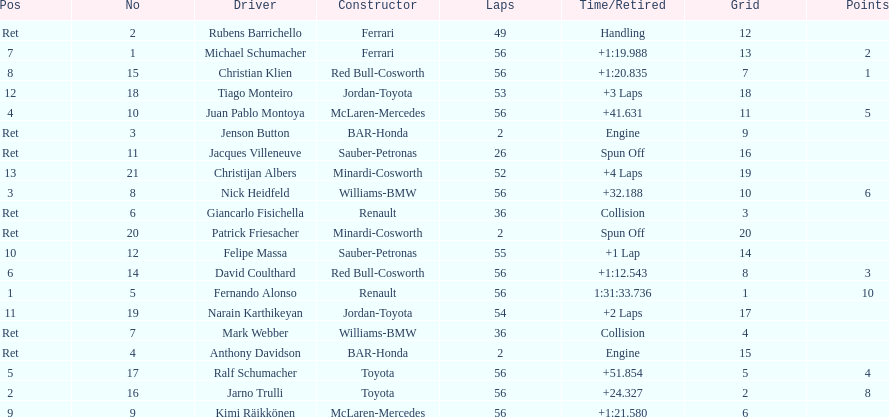In what amount of time did fernando alonso complete the race? 1:31:33.736. 